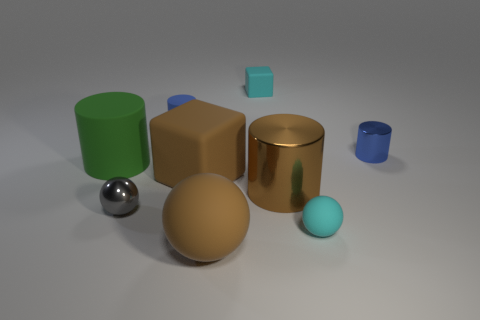Subtract all brown cylinders. How many cylinders are left? 3 Subtract all blue metal cylinders. How many cylinders are left? 3 Subtract all cylinders. How many objects are left? 5 Subtract 1 balls. How many balls are left? 2 Subtract all cyan cylinders. How many blue balls are left? 0 Subtract all green things. Subtract all green rubber cylinders. How many objects are left? 7 Add 4 large metal cylinders. How many large metal cylinders are left? 5 Add 8 brown cylinders. How many brown cylinders exist? 9 Subtract 1 gray spheres. How many objects are left? 8 Subtract all cyan spheres. Subtract all gray cylinders. How many spheres are left? 2 